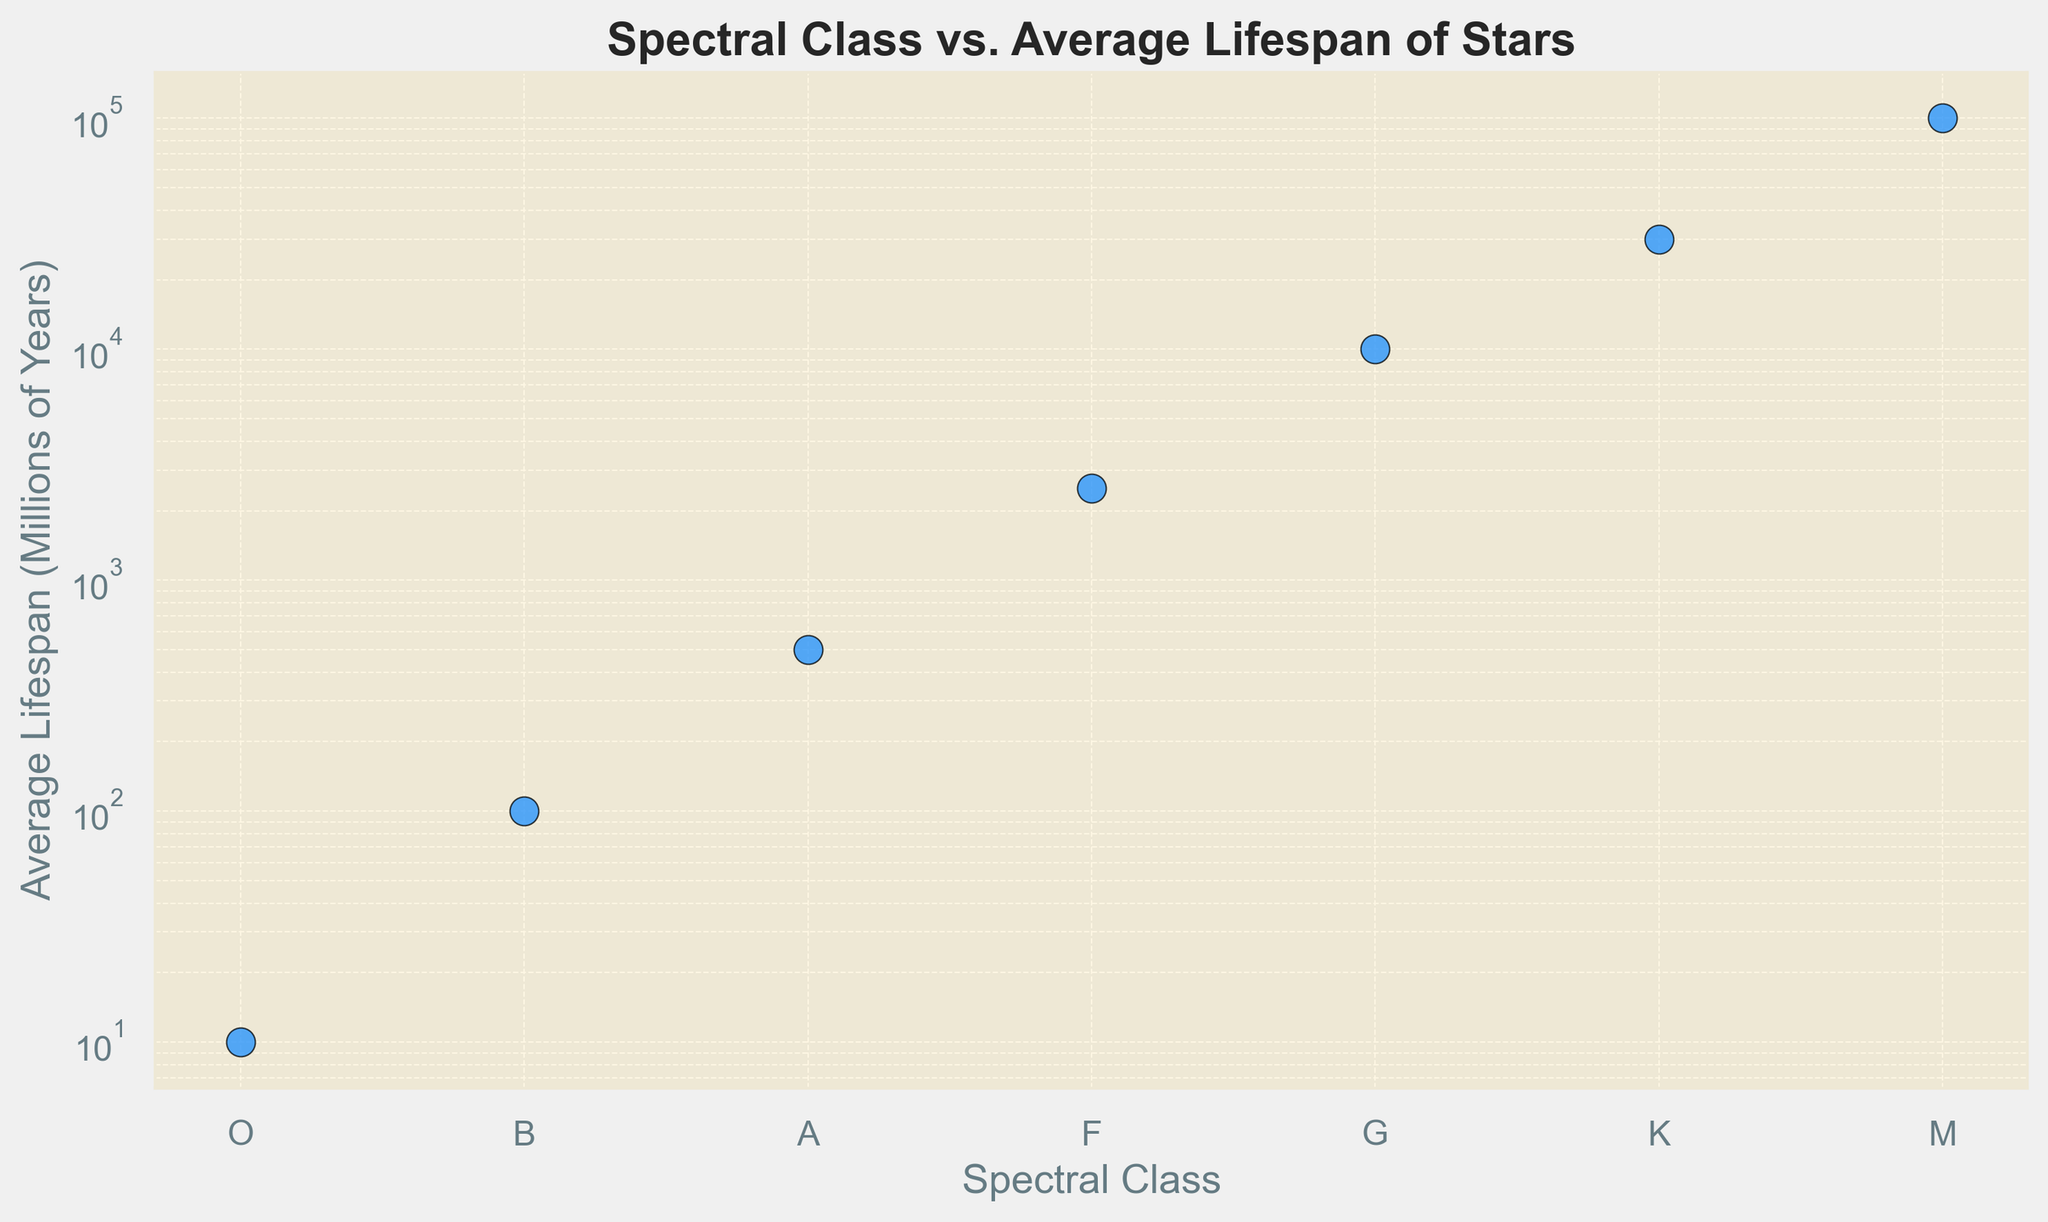What spectral class has the longest average lifespan? Look at the y-axis and identify which spectral class corresponds to the highest value on that axis. In this case, M stars have the longest lifespan.
Answer: M What is the ratio of the average lifespan of G-class stars to B-class stars? Find the average lifespan for G-class (10,000 million years) and B-class stars (100 million years). Then, divide the G-class lifespan by the B-class lifespan: 10,000 / 100 = 100.
Answer: 100 Which spectral class of stars has an average lifespan of 2500 million years? Locate the point on the scatter plot corresponding to 2500 million years on the y-axis and see the spectral class it aligns with. It aligns with F-class stars.
Answer: F How does the average lifespan of K-class stars compare to that of A-class stars? Look at the points corresponding to K-class (30,000 million years) and A-class (500 million years). K-class stars have a longer average lifespan.
Answer: K-class stars have a longer average lifespan What is the median lifespan of the spectral classes given? Arrange the lifespans in ascending order: 10, 100, 500, 2500, 10,000, 30,000, 100,000. The median is the middle value, which is 2500 million years.
Answer: 2500 million years Between which two spectral classes is the largest visual gap in average lifespan observed? Observe the scatter plot and identify the largest gap between consecutive points. The gap is largest between G-class (10,000 million years) and K-class (30,000 million years).
Answer: G and K What spectral class has a lifespan that is 100 times that of O-class stars? Analyzing the y-axis, M-class stars (100,000 million years) have a lifespan that is 100 times that of O-class stars (10 million years).
Answer: M How many spectral classes have an average lifespan of 10,000 million years or longer? Identify the points on the scatter plot that are above or equal to 10,000 million years on the y-axis. These are G, K, and M classes.
Answer: 3 If we double the lifespan of A-class stars, will it still be less than the lifespan of F-class stars? The average lifespan of A-class stars is 500 million years, and doubling it gives us 1000 million years. F-class stars have a lifespan of 2500 million years, which is still greater.
Answer: Yes 